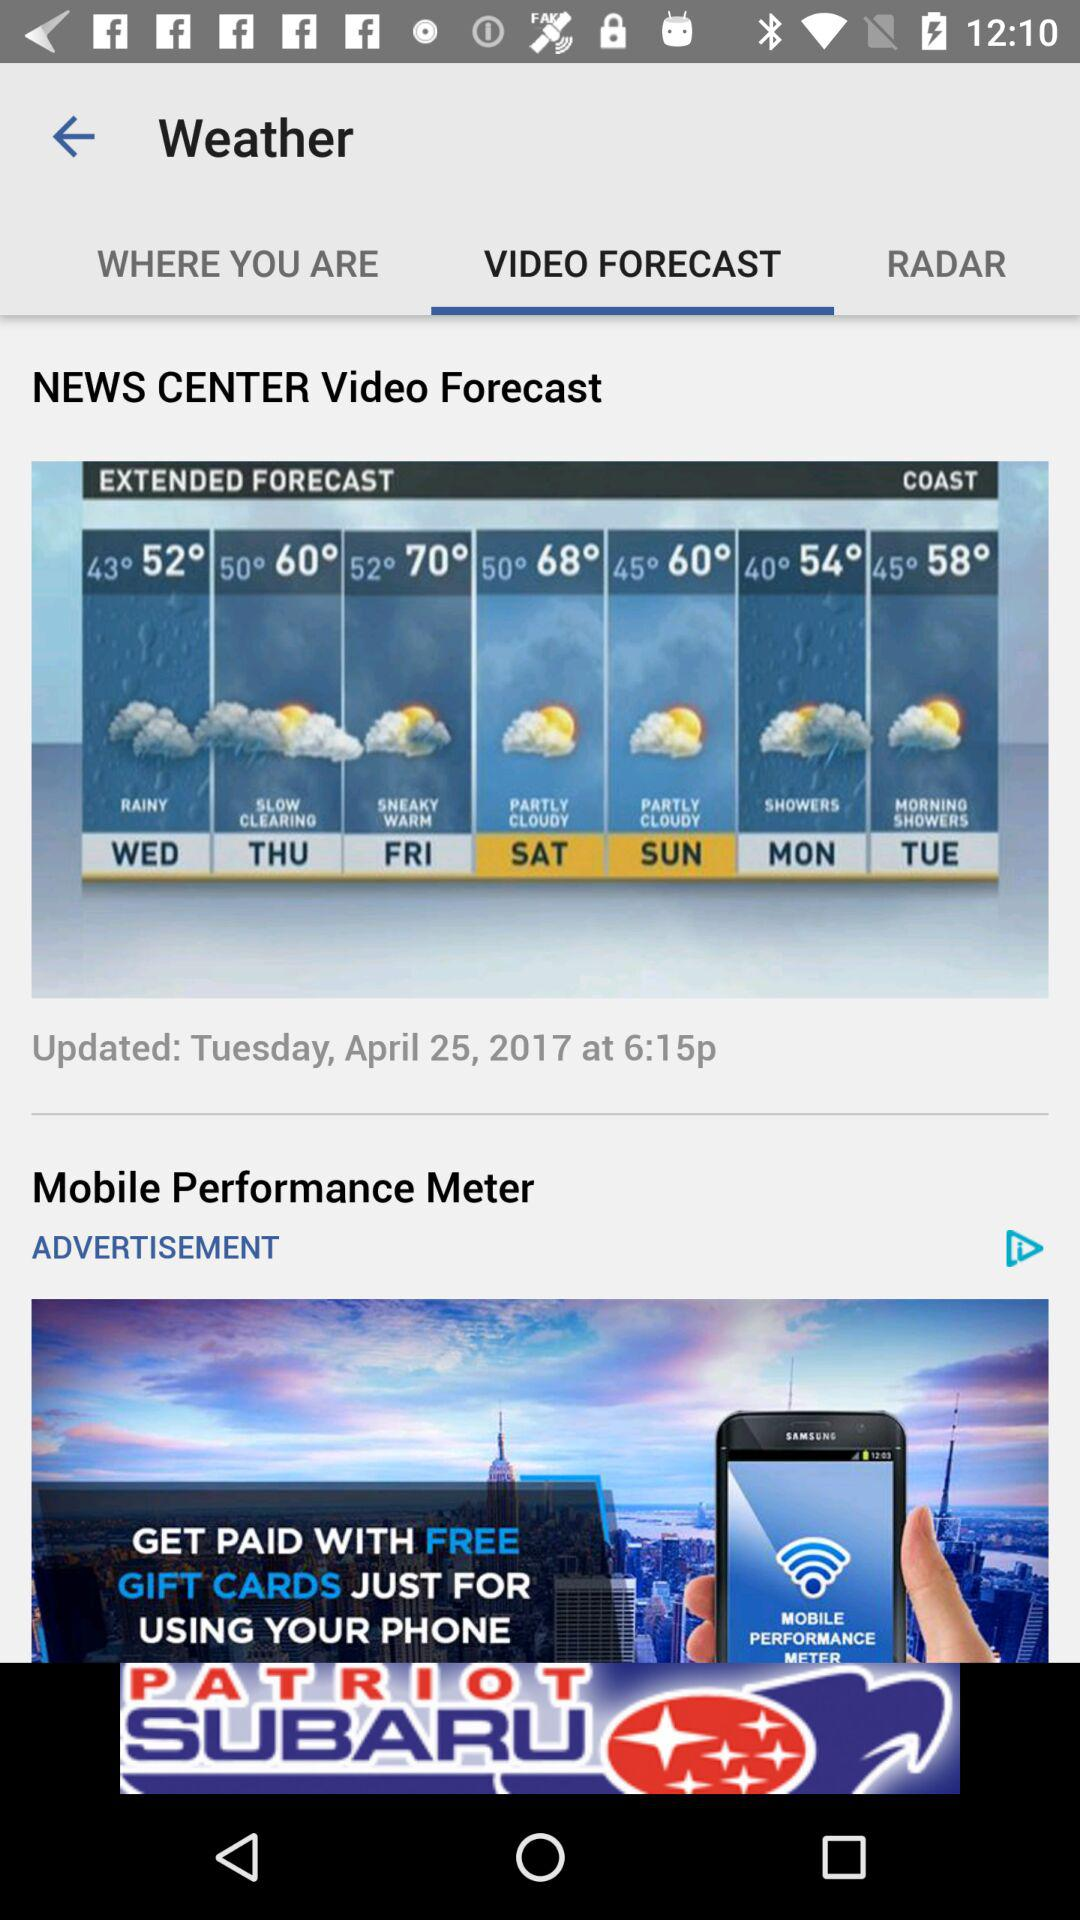What is the maximum and lowest temperature on friday?
When the provided information is insufficient, respond with <no answer>. <no answer> 